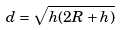Convert formula to latex. <formula><loc_0><loc_0><loc_500><loc_500>d = \sqrt { h ( 2 R + h ) }</formula> 